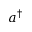<formula> <loc_0><loc_0><loc_500><loc_500>a ^ { \dagger }</formula> 